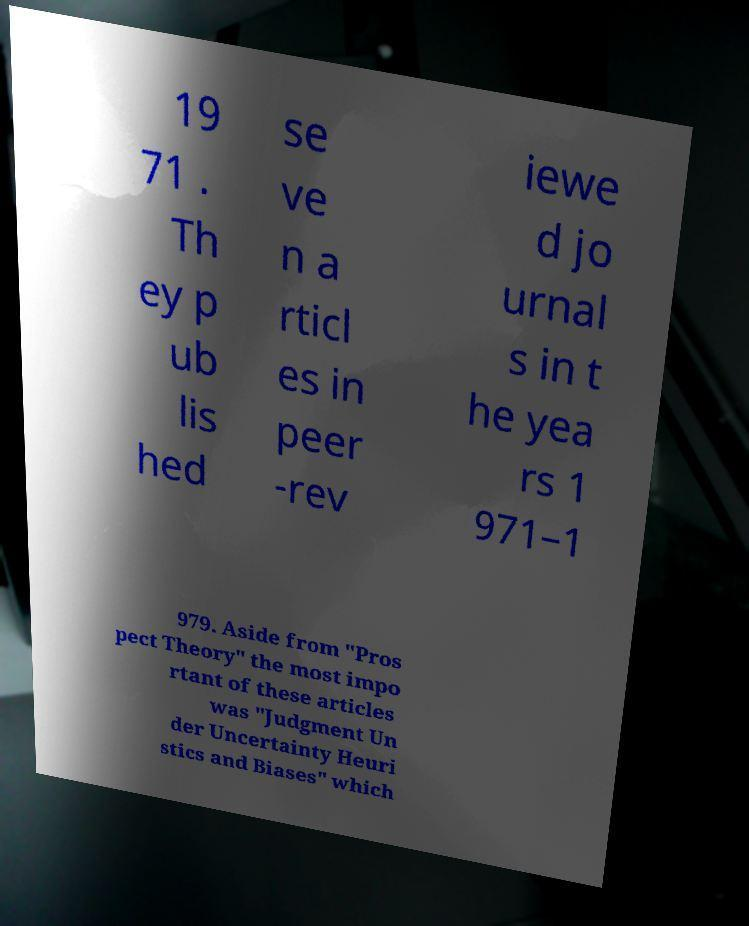For documentation purposes, I need the text within this image transcribed. Could you provide that? 19 71 . Th ey p ub lis hed se ve n a rticl es in peer -rev iewe d jo urnal s in t he yea rs 1 971–1 979. Aside from "Pros pect Theory" the most impo rtant of these articles was "Judgment Un der Uncertainty Heuri stics and Biases" which 